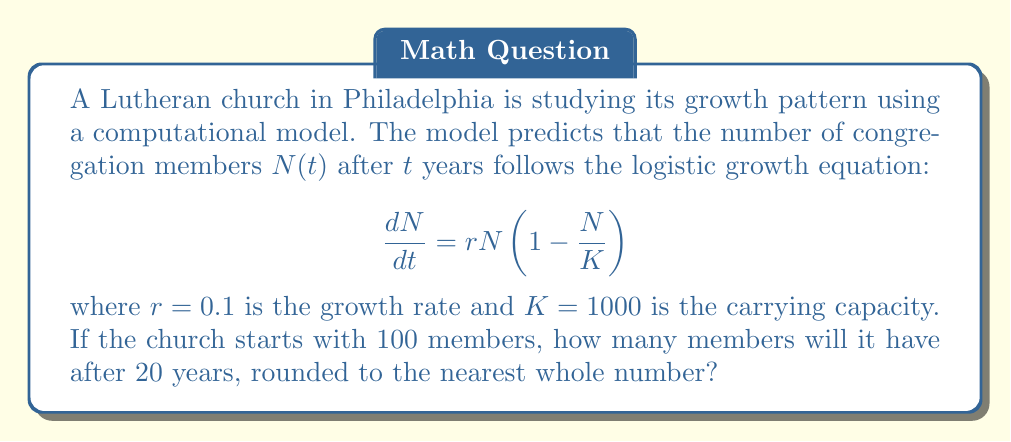Solve this math problem. To solve this problem, we need to use the solution to the logistic growth equation:

$$N(t) = \frac{K}{1 + (\frac{K}{N_0} - 1)e^{-rt}}$$

where $N_0$ is the initial population.

Given:
- $K = 1000$ (carrying capacity)
- $r = 0.1$ (growth rate)
- $N_0 = 100$ (initial population)
- $t = 20$ (time in years)

Let's substitute these values into the equation:

$$N(20) = \frac{1000}{1 + (\frac{1000}{100} - 1)e^{-0.1 \cdot 20}}$$

$$= \frac{1000}{1 + (10 - 1)e^{-2}}$$

$$= \frac{1000}{1 + 9e^{-2}}$$

Now, let's calculate this step-by-step:

1. Calculate $e^{-2}$:
   $e^{-2} \approx 0.1353$

2. Multiply by 9:
   $9 \cdot 0.1353 \approx 1.2177$

3. Add 1:
   $1 + 1.2177 = 2.2177$

4. Divide 1000 by this result:
   $\frac{1000}{2.2177} \approx 450.9158$

5. Round to the nearest whole number:
   451

Therefore, after 20 years, the church will have approximately 451 members.
Answer: 451 members 